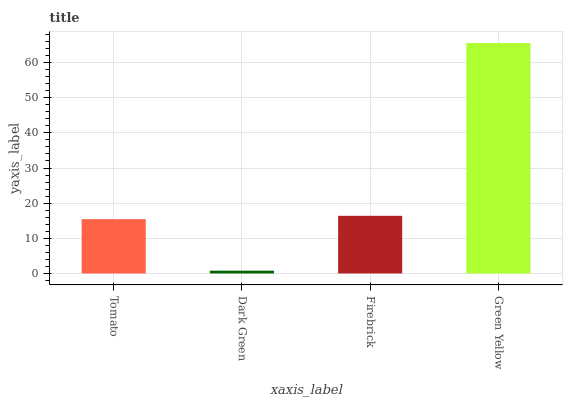Is Dark Green the minimum?
Answer yes or no. Yes. Is Green Yellow the maximum?
Answer yes or no. Yes. Is Firebrick the minimum?
Answer yes or no. No. Is Firebrick the maximum?
Answer yes or no. No. Is Firebrick greater than Dark Green?
Answer yes or no. Yes. Is Dark Green less than Firebrick?
Answer yes or no. Yes. Is Dark Green greater than Firebrick?
Answer yes or no. No. Is Firebrick less than Dark Green?
Answer yes or no. No. Is Firebrick the high median?
Answer yes or no. Yes. Is Tomato the low median?
Answer yes or no. Yes. Is Green Yellow the high median?
Answer yes or no. No. Is Green Yellow the low median?
Answer yes or no. No. 